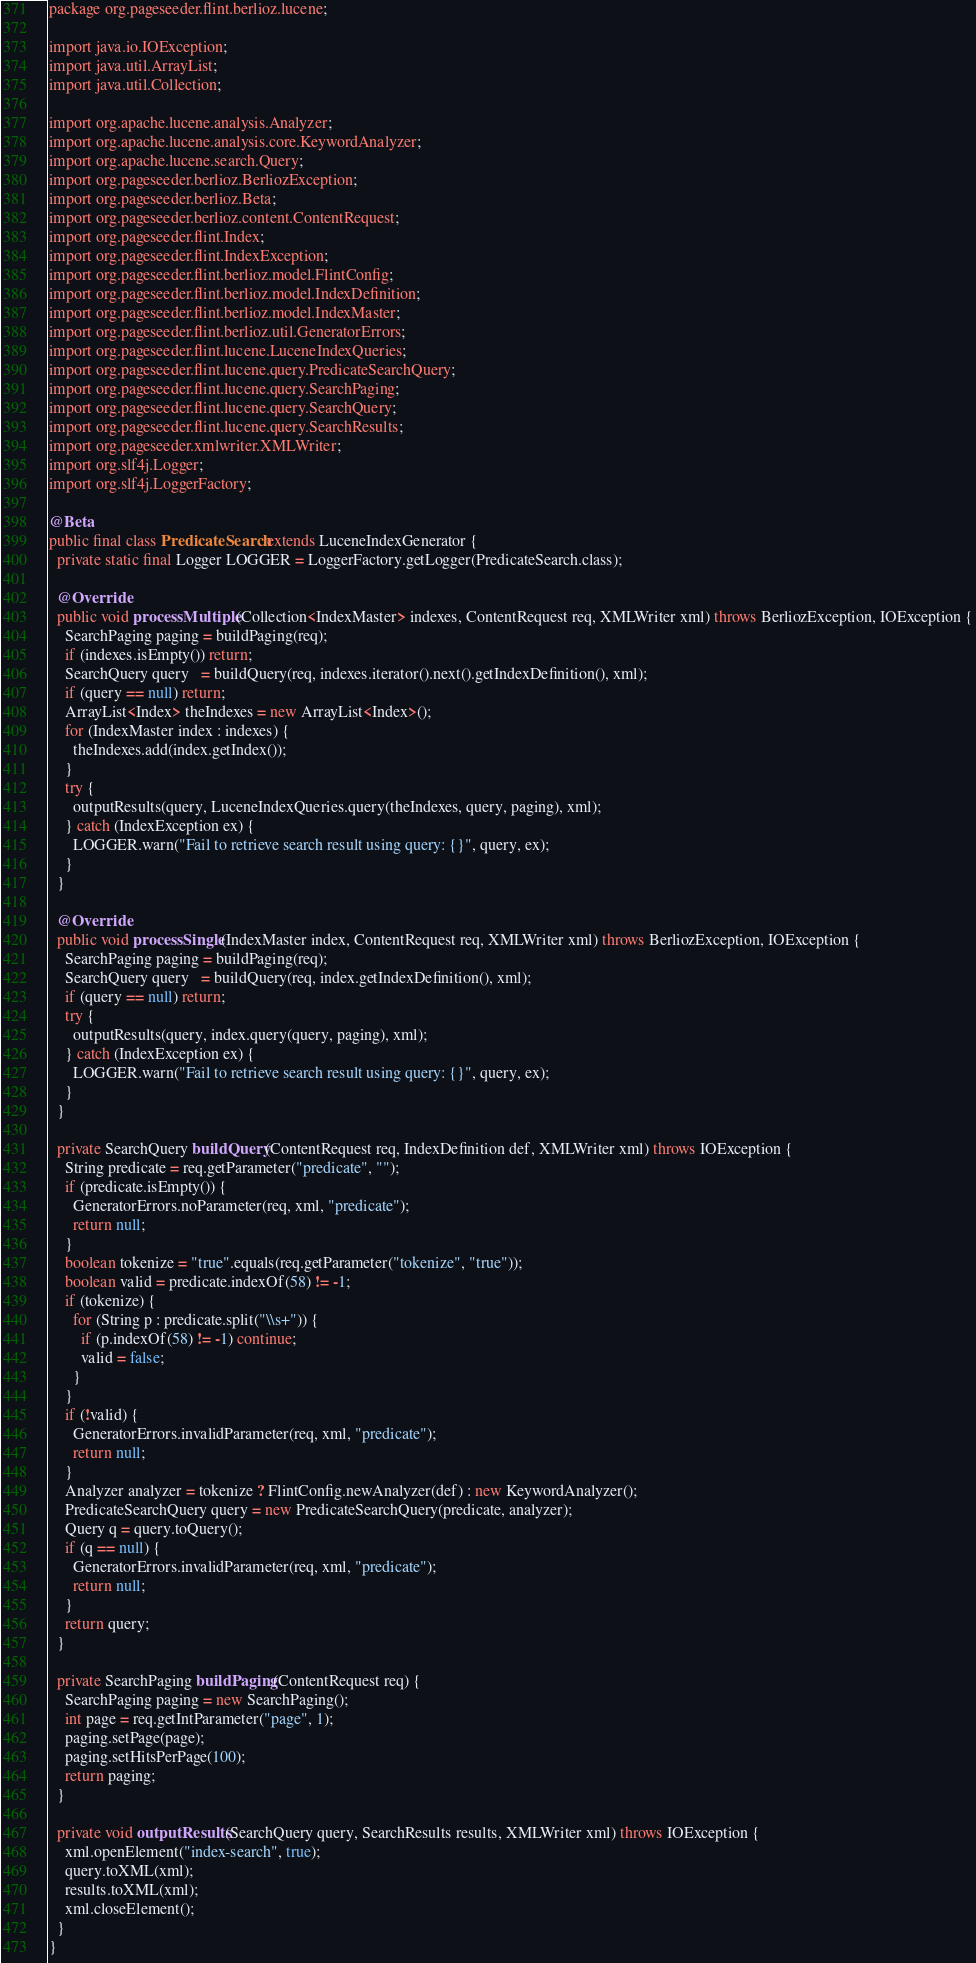<code> <loc_0><loc_0><loc_500><loc_500><_Java_>package org.pageseeder.flint.berlioz.lucene;

import java.io.IOException;
import java.util.ArrayList;
import java.util.Collection;

import org.apache.lucene.analysis.Analyzer;
import org.apache.lucene.analysis.core.KeywordAnalyzer;
import org.apache.lucene.search.Query;
import org.pageseeder.berlioz.BerliozException;
import org.pageseeder.berlioz.Beta;
import org.pageseeder.berlioz.content.ContentRequest;
import org.pageseeder.flint.Index;
import org.pageseeder.flint.IndexException;
import org.pageseeder.flint.berlioz.model.FlintConfig;
import org.pageseeder.flint.berlioz.model.IndexDefinition;
import org.pageseeder.flint.berlioz.model.IndexMaster;
import org.pageseeder.flint.berlioz.util.GeneratorErrors;
import org.pageseeder.flint.lucene.LuceneIndexQueries;
import org.pageseeder.flint.lucene.query.PredicateSearchQuery;
import org.pageseeder.flint.lucene.query.SearchPaging;
import org.pageseeder.flint.lucene.query.SearchQuery;
import org.pageseeder.flint.lucene.query.SearchResults;
import org.pageseeder.xmlwriter.XMLWriter;
import org.slf4j.Logger;
import org.slf4j.LoggerFactory;

@Beta
public final class PredicateSearch extends LuceneIndexGenerator {
  private static final Logger LOGGER = LoggerFactory.getLogger(PredicateSearch.class);

  @Override
  public void processMultiple(Collection<IndexMaster> indexes, ContentRequest req, XMLWriter xml) throws BerliozException, IOException {
    SearchPaging paging = buildPaging(req);
    if (indexes.isEmpty()) return;
    SearchQuery query   = buildQuery(req, indexes.iterator().next().getIndexDefinition(), xml);
    if (query == null) return;
    ArrayList<Index> theIndexes = new ArrayList<Index>();
    for (IndexMaster index : indexes) {
      theIndexes.add(index.getIndex());
    }
    try {
      outputResults(query, LuceneIndexQueries.query(theIndexes, query, paging), xml);
    } catch (IndexException ex) {
      LOGGER.warn("Fail to retrieve search result using query: {}", query, ex);
    }
  }

  @Override
  public void processSingle(IndexMaster index, ContentRequest req, XMLWriter xml) throws BerliozException, IOException {
    SearchPaging paging = buildPaging(req);
    SearchQuery query   = buildQuery(req, index.getIndexDefinition(), xml);
    if (query == null) return;
    try {
      outputResults(query, index.query(query, paging), xml);
    } catch (IndexException ex) {
      LOGGER.warn("Fail to retrieve search result using query: {}", query, ex);
    }
  }

  private SearchQuery buildQuery(ContentRequest req, IndexDefinition def, XMLWriter xml) throws IOException {
    String predicate = req.getParameter("predicate", "");
    if (predicate.isEmpty()) {
      GeneratorErrors.noParameter(req, xml, "predicate");
      return null;
    }
    boolean tokenize = "true".equals(req.getParameter("tokenize", "true"));
    boolean valid = predicate.indexOf(58) != -1;
    if (tokenize) {
      for (String p : predicate.split("\\s+")) {
        if (p.indexOf(58) != -1) continue;
        valid = false;
      }
    }
    if (!valid) {
      GeneratorErrors.invalidParameter(req, xml, "predicate");
      return null;
    }
    Analyzer analyzer = tokenize ? FlintConfig.newAnalyzer(def) : new KeywordAnalyzer();
    PredicateSearchQuery query = new PredicateSearchQuery(predicate, analyzer);
    Query q = query.toQuery();
    if (q == null) {
      GeneratorErrors.invalidParameter(req, xml, "predicate");
      return null;
    }
    return query;
  }

  private SearchPaging buildPaging(ContentRequest req) {
    SearchPaging paging = new SearchPaging();
    int page = req.getIntParameter("page", 1);
    paging.setPage(page);
    paging.setHitsPerPage(100);
    return paging;
  }

  private void outputResults(SearchQuery query, SearchResults results, XMLWriter xml) throws IOException {
    xml.openElement("index-search", true);
    query.toXML(xml);
    results.toXML(xml);
    xml.closeElement();
  }
}
</code> 